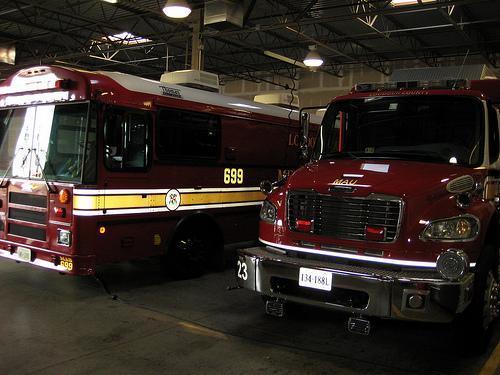How many vehicles are visible?
Give a very brief answer. 2. 